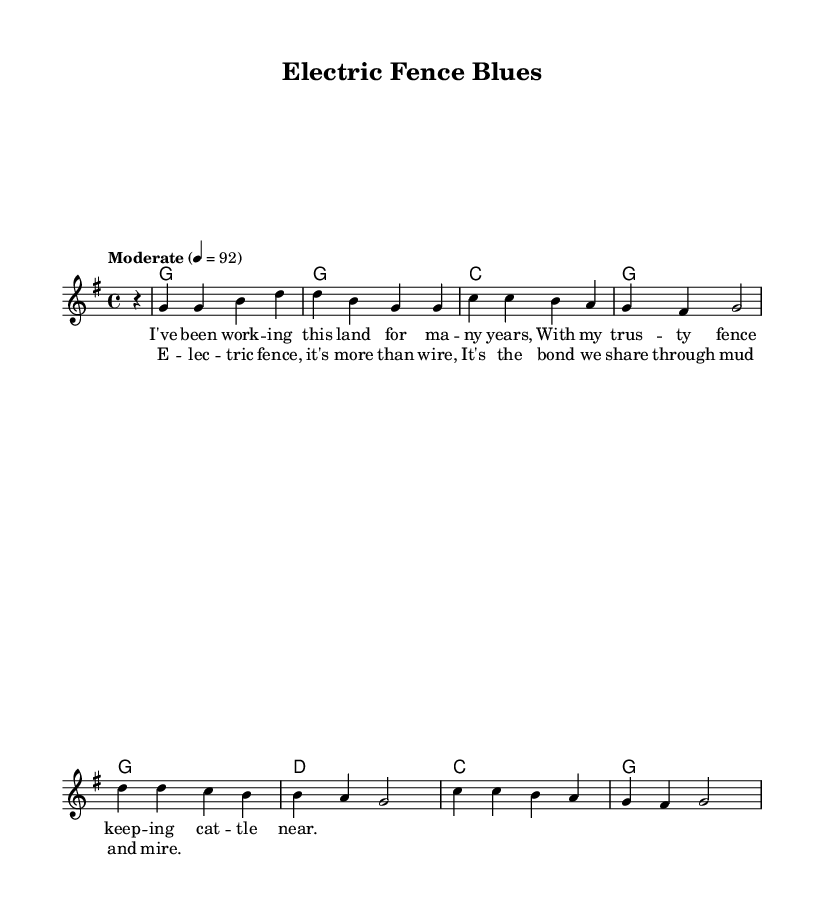What is the key signature of this music? The key signature indicated at the beginning of the score is one sharp, which corresponds to G major.
Answer: G major What is the time signature of this music? The time signature shown at the beginning of the score is written as a "4/4", meaning there are 4 beats in each measure.
Answer: 4/4 What is the tempo marking for this piece? The tempo marking specifies "Moderate" with a BPM (beats per minute) of 92, indicating a moderate pace for the performance.
Answer: Moderate 92 How many measures are in the chorus? By counting the number of lines in the chorus section, we see that there are 2 measures present.
Answer: 2 measures What instrument is primarily featured in this score? The primary instrument indicated in the score is a voice, as the melody is specifically written for a lead voice.
Answer: Voice What lyrical theme is presented in the chorus? The chorus expresses a heartfelt bond characterized by resilience and connection, emphasizing the emotional relationship through the imagery of an electric fence.
Answer: Bond through mud and mire How does the melody move in the first two measures? The melody starts at a G note and ascends to a B, then descends back down to a G note over the first two measures, creating a melodic pattern.
Answer: Ascending and descending 